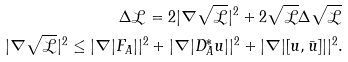Convert formula to latex. <formula><loc_0><loc_0><loc_500><loc_500>\Delta \mathcal { L } = 2 | \nabla \sqrt { \mathcal { L } } | ^ { 2 } + 2 \sqrt { \mathcal { L } } \Delta \sqrt { \mathcal { L } } \\ | \nabla \sqrt { \mathcal { L } } | ^ { 2 } \leq | \nabla | F _ { A } | | ^ { 2 } + | \nabla | D ^ { * } _ { A } u | | ^ { 2 } + | \nabla | [ u , \bar { u } ] | | ^ { 2 } .</formula> 